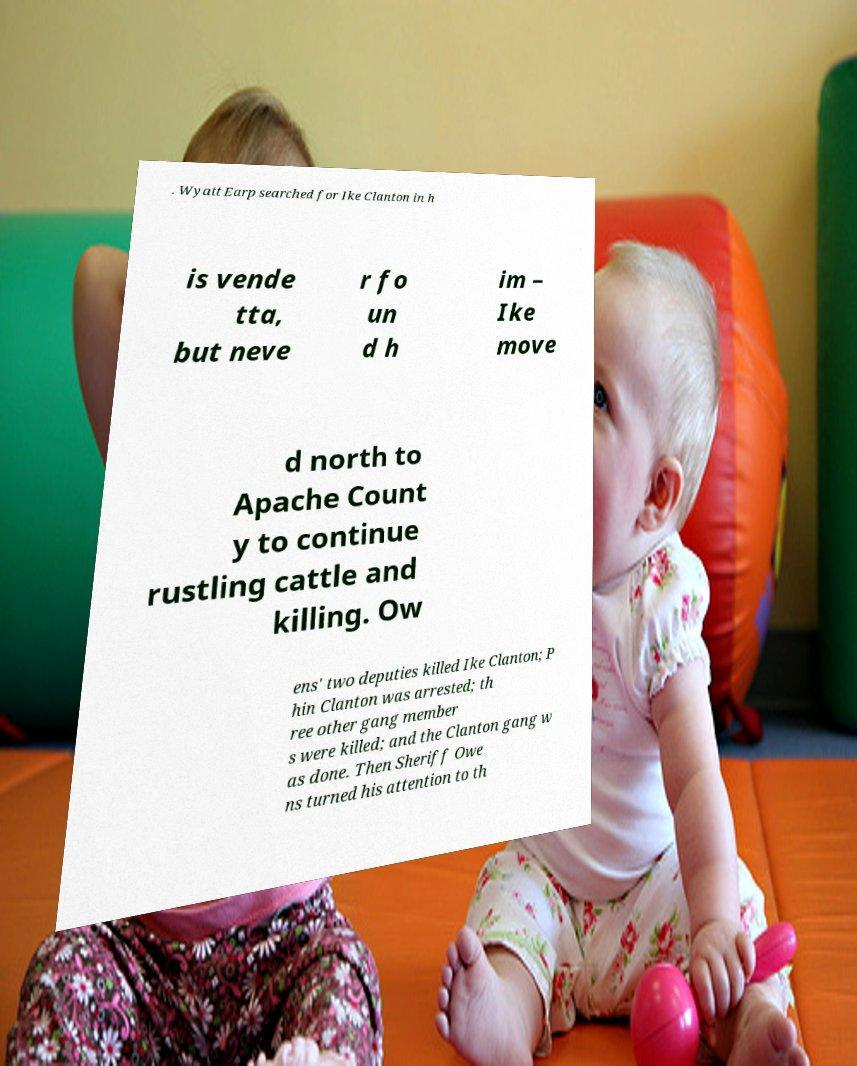For documentation purposes, I need the text within this image transcribed. Could you provide that? . Wyatt Earp searched for Ike Clanton in h is vende tta, but neve r fo un d h im – Ike move d north to Apache Count y to continue rustling cattle and killing. Ow ens' two deputies killed Ike Clanton; P hin Clanton was arrested; th ree other gang member s were killed; and the Clanton gang w as done. Then Sheriff Owe ns turned his attention to th 